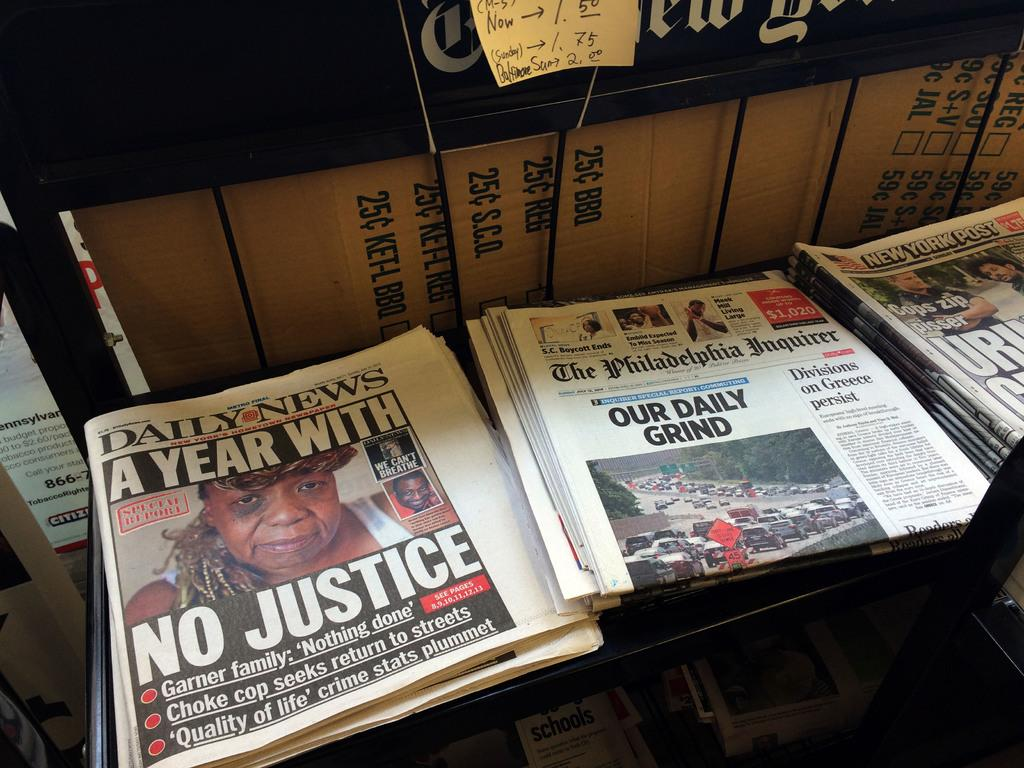<image>
Create a compact narrative representing the image presented. The Daily News front page proclaims A Year With No Justice. 